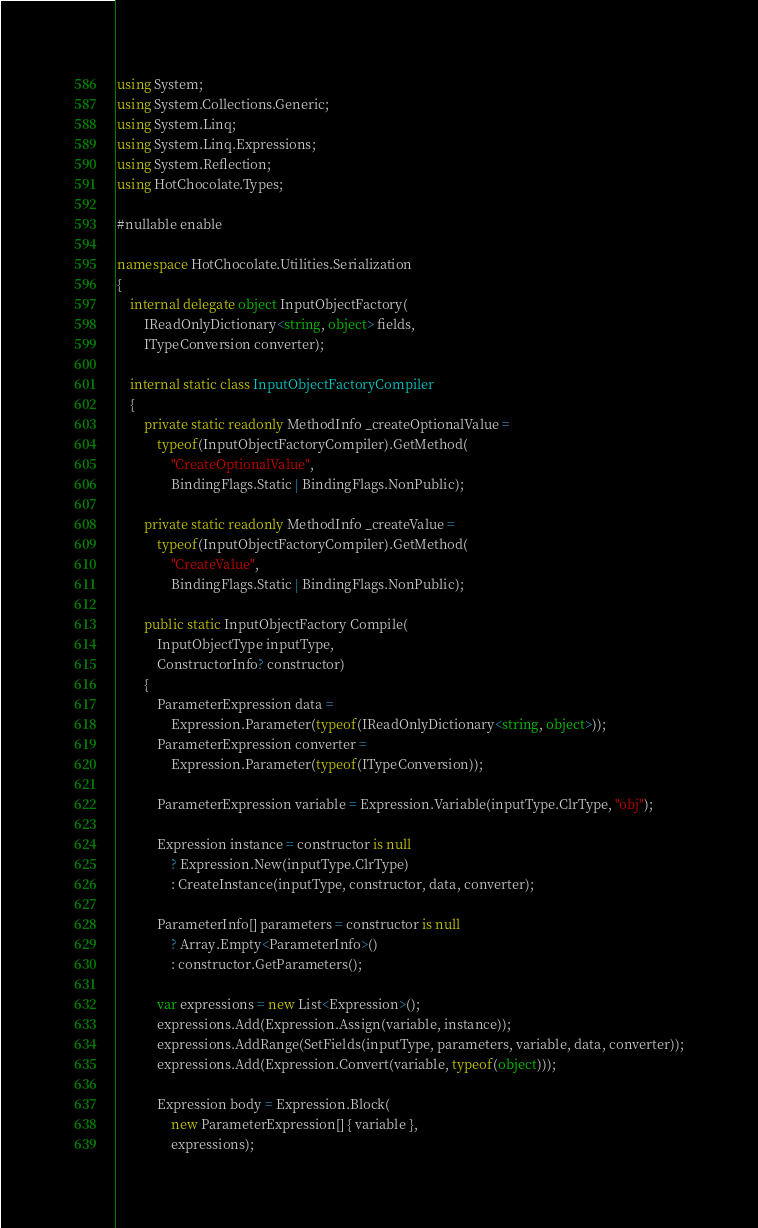Convert code to text. <code><loc_0><loc_0><loc_500><loc_500><_C#_>using System;
using System.Collections.Generic;
using System.Linq;
using System.Linq.Expressions;
using System.Reflection;
using HotChocolate.Types;

#nullable enable

namespace HotChocolate.Utilities.Serialization
{
    internal delegate object InputObjectFactory(
        IReadOnlyDictionary<string, object> fields,
        ITypeConversion converter);

    internal static class InputObjectFactoryCompiler
    {
        private static readonly MethodInfo _createOptionalValue =
            typeof(InputObjectFactoryCompiler).GetMethod(
                "CreateOptionalValue",
                BindingFlags.Static | BindingFlags.NonPublic);

        private static readonly MethodInfo _createValue =
            typeof(InputObjectFactoryCompiler).GetMethod(
                "CreateValue",
                BindingFlags.Static | BindingFlags.NonPublic);

        public static InputObjectFactory Compile(
            InputObjectType inputType,
            ConstructorInfo? constructor)
        {
            ParameterExpression data =
                Expression.Parameter(typeof(IReadOnlyDictionary<string, object>));
            ParameterExpression converter =
                Expression.Parameter(typeof(ITypeConversion));

            ParameterExpression variable = Expression.Variable(inputType.ClrType, "obj");

            Expression instance = constructor is null
                ? Expression.New(inputType.ClrType)
                : CreateInstance(inputType, constructor, data, converter);

            ParameterInfo[] parameters = constructor is null
                ? Array.Empty<ParameterInfo>()
                : constructor.GetParameters();

            var expressions = new List<Expression>();
            expressions.Add(Expression.Assign(variable, instance));
            expressions.AddRange(SetFields(inputType, parameters, variable, data, converter));
            expressions.Add(Expression.Convert(variable, typeof(object)));

            Expression body = Expression.Block(
                new ParameterExpression[] { variable },
                expressions);
</code> 